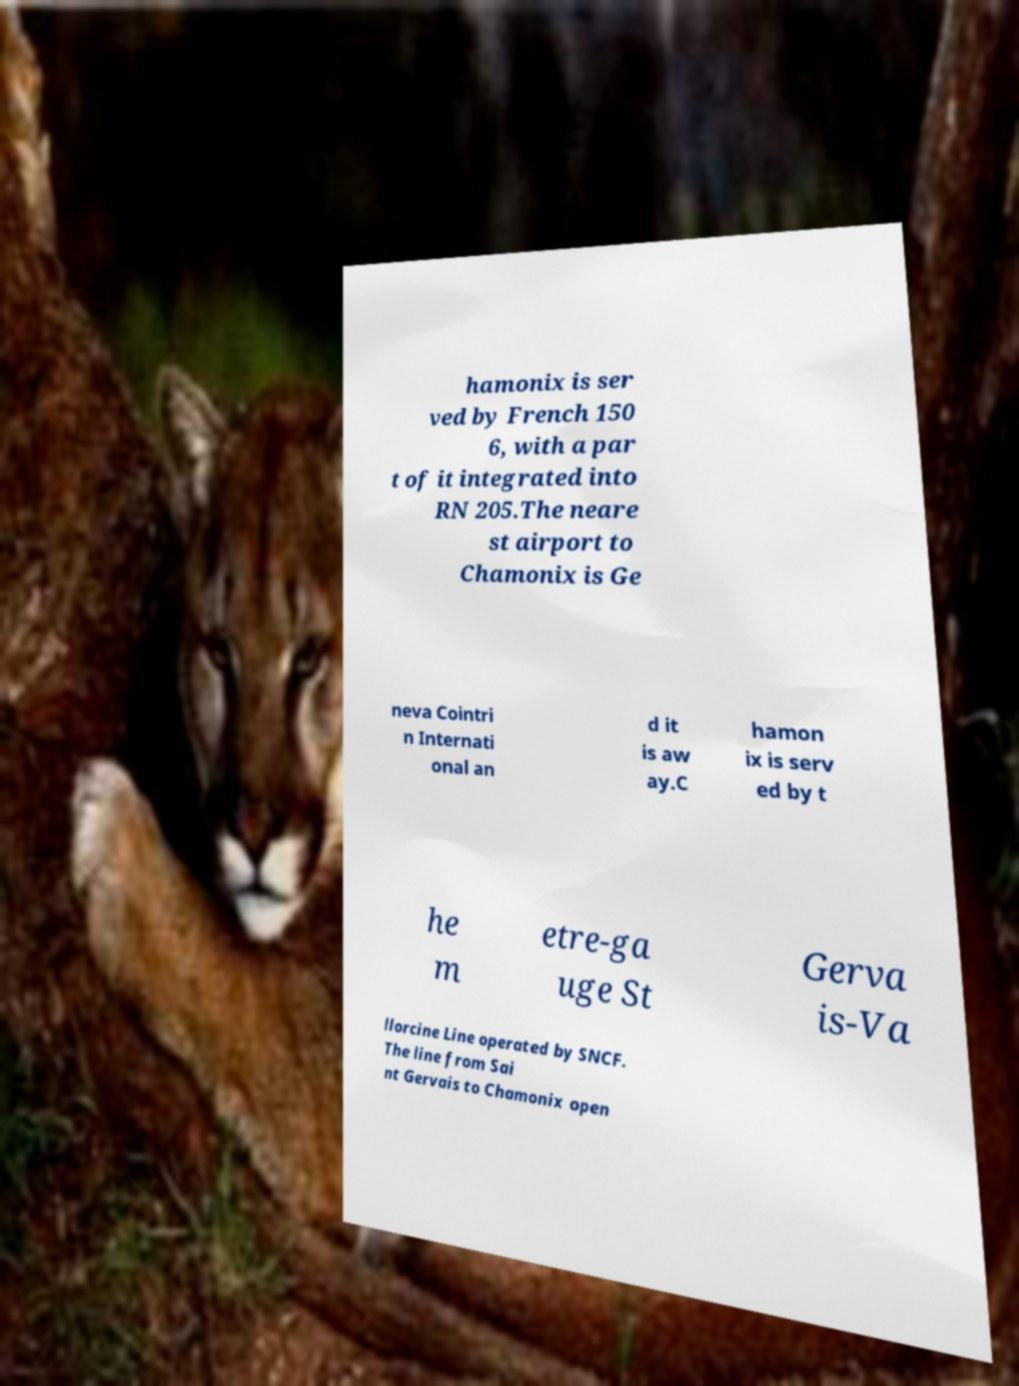For documentation purposes, I need the text within this image transcribed. Could you provide that? hamonix is ser ved by French 150 6, with a par t of it integrated into RN 205.The neare st airport to Chamonix is Ge neva Cointri n Internati onal an d it is aw ay.C hamon ix is serv ed by t he m etre-ga uge St Gerva is-Va llorcine Line operated by SNCF. The line from Sai nt Gervais to Chamonix open 